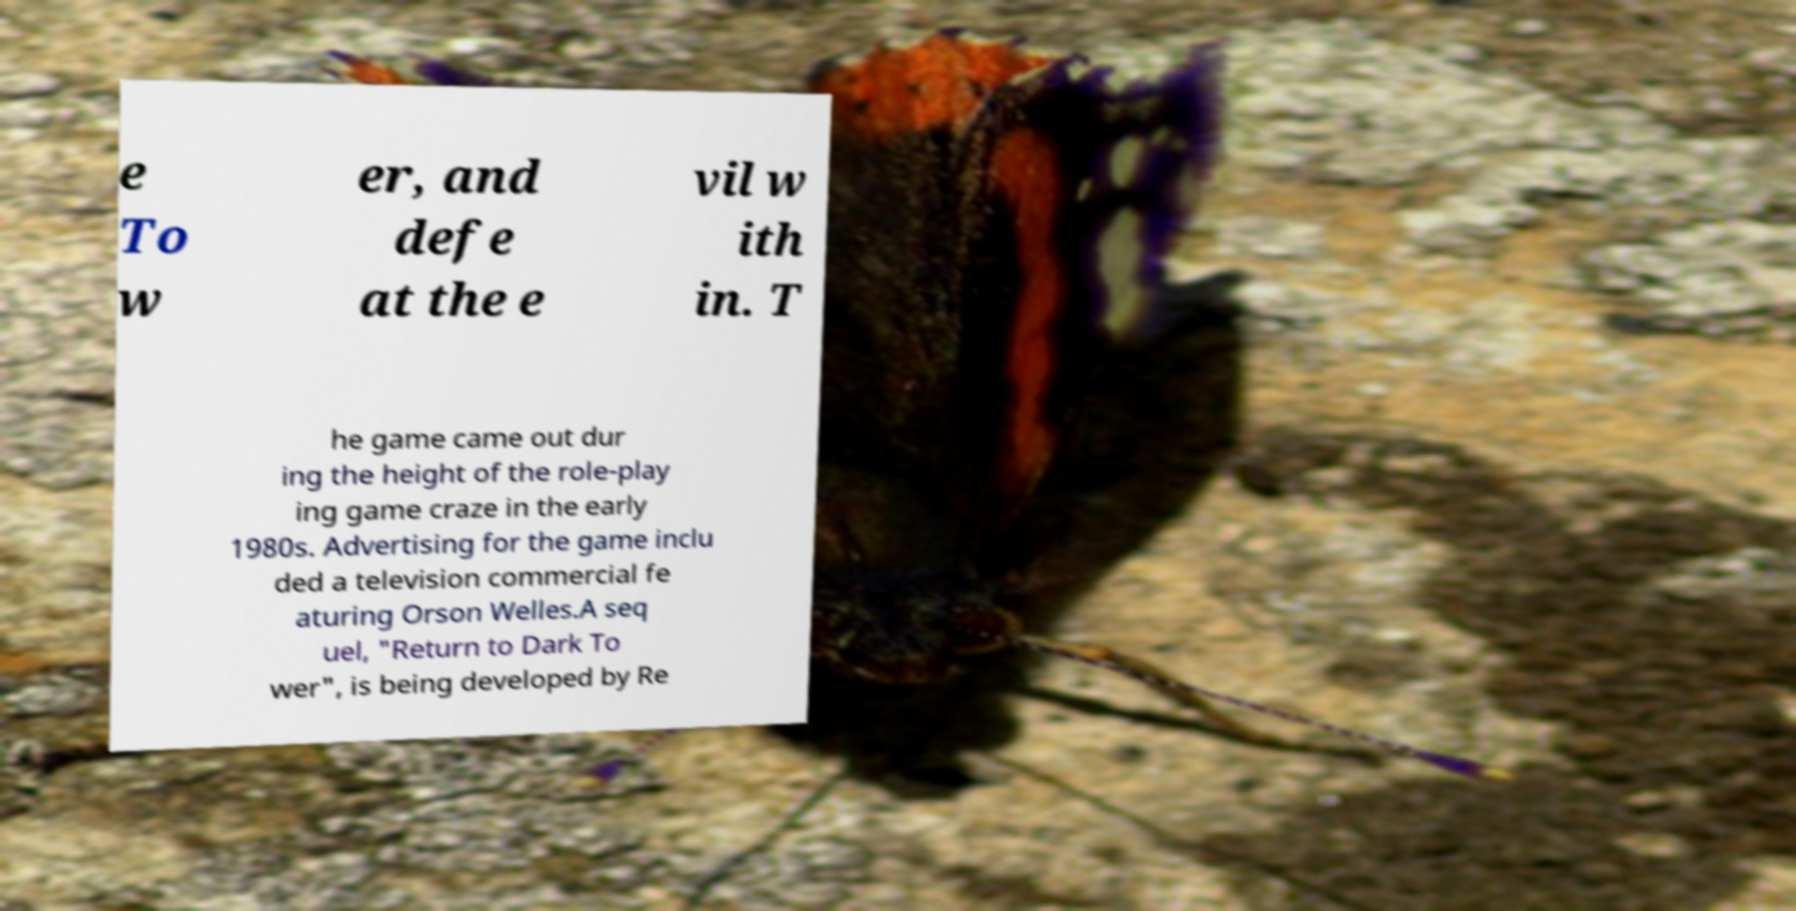Can you read and provide the text displayed in the image?This photo seems to have some interesting text. Can you extract and type it out for me? e To w er, and defe at the e vil w ith in. T he game came out dur ing the height of the role-play ing game craze in the early 1980s. Advertising for the game inclu ded a television commercial fe aturing Orson Welles.A seq uel, "Return to Dark To wer", is being developed by Re 